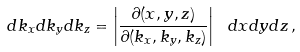<formula> <loc_0><loc_0><loc_500><loc_500>d k _ { x } d k _ { y } d k _ { z } = \left | \frac { \partial ( x , y , z ) } { \partial ( k _ { x } , k _ { y } , k _ { z } ) } \right | \ d x d y d z \, ,</formula> 